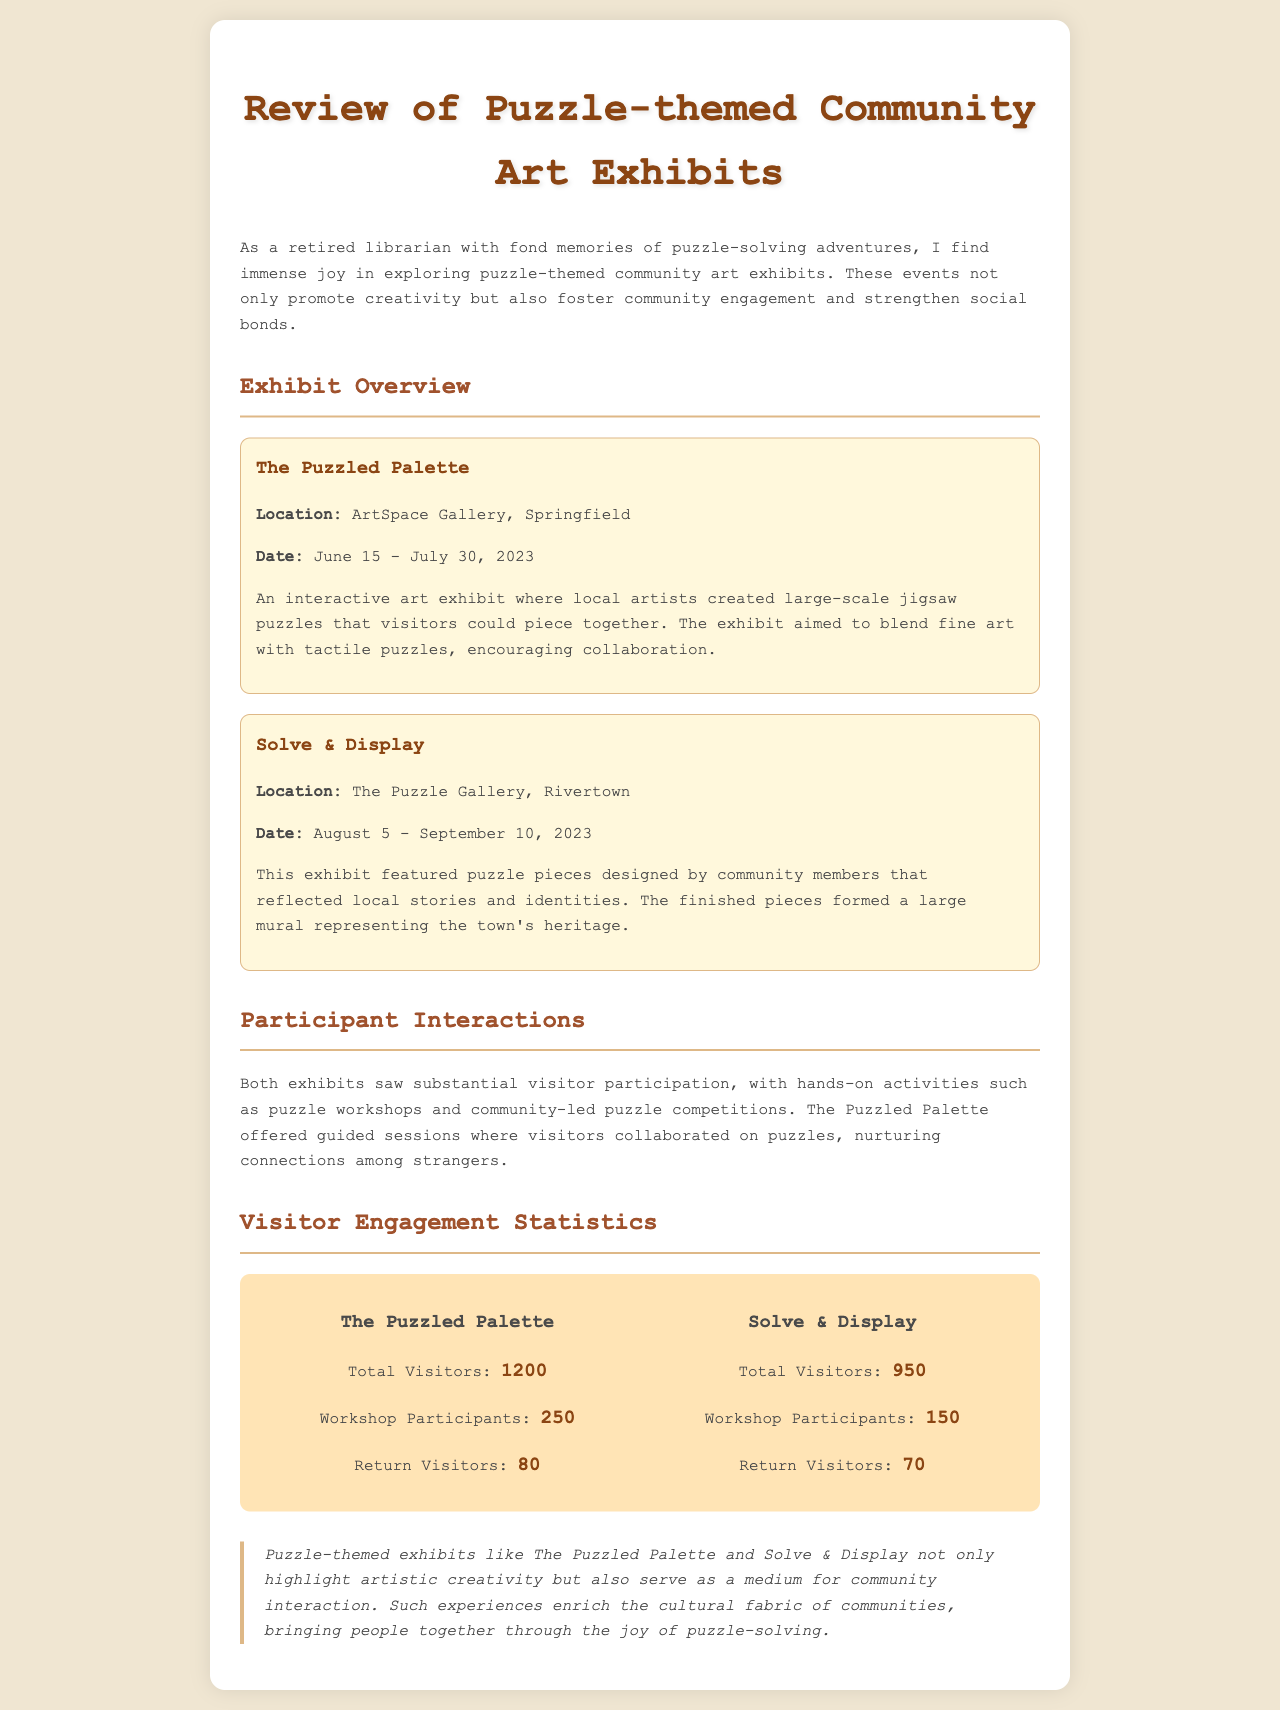What was the location of The Puzzled Palette? The location is specified in the exhibit overview section as ArtSpace Gallery, Springfield.
Answer: ArtSpace Gallery, Springfield What were the dates for the Solve & Display exhibit? The dates for the exhibit are provided in the overview section, from August 5 to September 10, 2023.
Answer: August 5 - September 10, 2023 How many total visitors attended The Puzzled Palette? The total visitor count is detailed in the visitor engagement statistics for The Puzzled Palette, indicating 1200 total visitors.
Answer: 1200 What was the number of workshop participants for Solve & Display? The document mentions the number of workshop participants for Solve & Display as 150 in the statistics section.
Answer: 150 What is the main purpose of the community art exhibits as stated in the conclusion? The conclusion elaborates that the purpose is to highlight artistic creativity and serve as a medium for community interaction.
Answer: Highlight artistic creativity and serve as a medium for community interaction Which exhibit had a higher count of return visitors? By comparing the return visitor statistics, it is noted that The Puzzled Palette had 80 return visitors compared to 70 for Solve & Display.
Answer: The Puzzled Palette What activities did both exhibits offer for visitor participation? The document states that both exhibits offered hands-on activities, such as puzzle workshops and community-led puzzle competitions.
Answer: Puzzle workshops and community-led puzzle competitions What type of art was featured in The Puzzled Palette? The overview describes the art featured as large-scale jigsaw puzzles created by local artists.
Answer: Large-scale jigsaw puzzles 